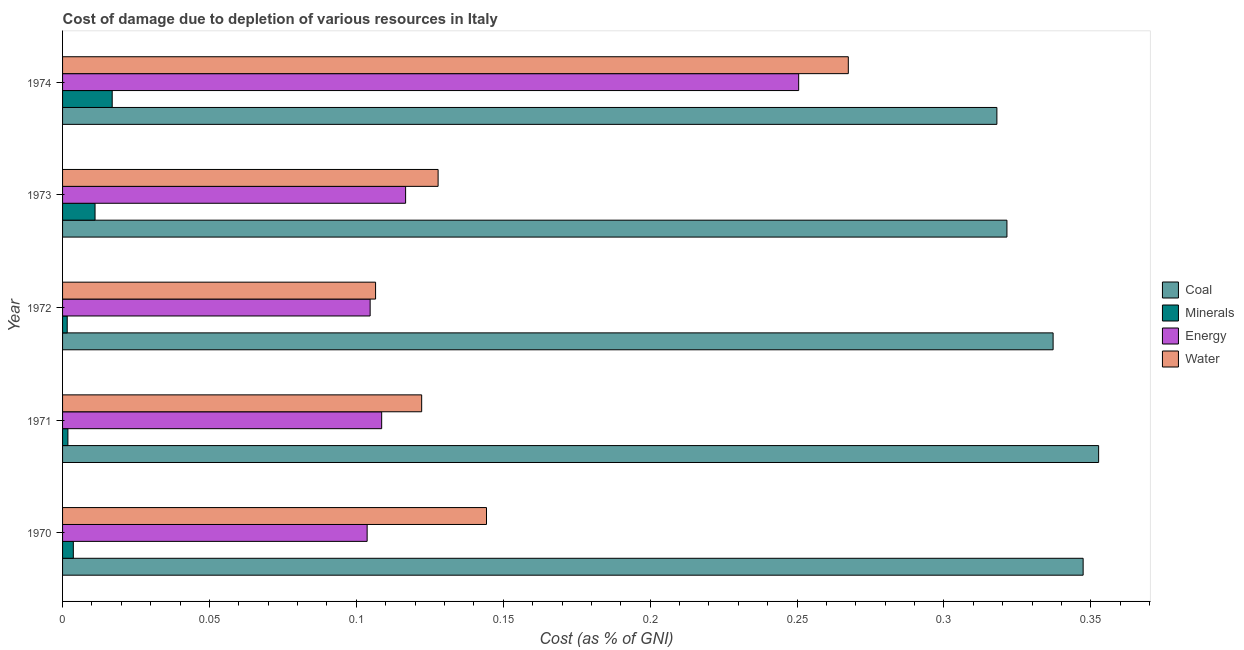How many different coloured bars are there?
Provide a short and direct response. 4. How many bars are there on the 5th tick from the top?
Give a very brief answer. 4. How many bars are there on the 5th tick from the bottom?
Ensure brevity in your answer.  4. What is the label of the 3rd group of bars from the top?
Keep it short and to the point. 1972. What is the cost of damage due to depletion of coal in 1974?
Keep it short and to the point. 0.32. Across all years, what is the maximum cost of damage due to depletion of coal?
Give a very brief answer. 0.35. Across all years, what is the minimum cost of damage due to depletion of energy?
Ensure brevity in your answer.  0.1. In which year was the cost of damage due to depletion of energy maximum?
Your answer should be compact. 1974. What is the total cost of damage due to depletion of water in the graph?
Provide a short and direct response. 0.77. What is the difference between the cost of damage due to depletion of energy in 1970 and that in 1973?
Provide a short and direct response. -0.01. What is the difference between the cost of damage due to depletion of energy in 1970 and the cost of damage due to depletion of water in 1974?
Provide a succinct answer. -0.16. What is the average cost of damage due to depletion of energy per year?
Your answer should be very brief. 0.14. In the year 1971, what is the difference between the cost of damage due to depletion of water and cost of damage due to depletion of energy?
Make the answer very short. 0.01. What is the ratio of the cost of damage due to depletion of coal in 1972 to that in 1973?
Your response must be concise. 1.05. Is the difference between the cost of damage due to depletion of water in 1971 and 1972 greater than the difference between the cost of damage due to depletion of coal in 1971 and 1972?
Offer a very short reply. Yes. What is the difference between the highest and the second highest cost of damage due to depletion of coal?
Keep it short and to the point. 0.01. Is it the case that in every year, the sum of the cost of damage due to depletion of energy and cost of damage due to depletion of water is greater than the sum of cost of damage due to depletion of coal and cost of damage due to depletion of minerals?
Your answer should be compact. No. What does the 3rd bar from the top in 1972 represents?
Offer a terse response. Minerals. What does the 3rd bar from the bottom in 1973 represents?
Your answer should be compact. Energy. How many bars are there?
Keep it short and to the point. 20. What is the difference between two consecutive major ticks on the X-axis?
Your response must be concise. 0.05. Does the graph contain grids?
Provide a short and direct response. No. How many legend labels are there?
Your response must be concise. 4. How are the legend labels stacked?
Offer a very short reply. Vertical. What is the title of the graph?
Your answer should be compact. Cost of damage due to depletion of various resources in Italy . What is the label or title of the X-axis?
Your answer should be very brief. Cost (as % of GNI). What is the label or title of the Y-axis?
Provide a short and direct response. Year. What is the Cost (as % of GNI) in Coal in 1970?
Provide a succinct answer. 0.35. What is the Cost (as % of GNI) in Minerals in 1970?
Provide a succinct answer. 0. What is the Cost (as % of GNI) in Energy in 1970?
Keep it short and to the point. 0.1. What is the Cost (as % of GNI) in Water in 1970?
Keep it short and to the point. 0.14. What is the Cost (as % of GNI) of Coal in 1971?
Your response must be concise. 0.35. What is the Cost (as % of GNI) of Minerals in 1971?
Keep it short and to the point. 0. What is the Cost (as % of GNI) in Energy in 1971?
Your answer should be very brief. 0.11. What is the Cost (as % of GNI) in Water in 1971?
Offer a very short reply. 0.12. What is the Cost (as % of GNI) of Coal in 1972?
Make the answer very short. 0.34. What is the Cost (as % of GNI) of Minerals in 1972?
Keep it short and to the point. 0. What is the Cost (as % of GNI) of Energy in 1972?
Provide a succinct answer. 0.1. What is the Cost (as % of GNI) of Water in 1972?
Provide a short and direct response. 0.11. What is the Cost (as % of GNI) in Coal in 1973?
Offer a terse response. 0.32. What is the Cost (as % of GNI) of Minerals in 1973?
Give a very brief answer. 0.01. What is the Cost (as % of GNI) in Energy in 1973?
Your answer should be very brief. 0.12. What is the Cost (as % of GNI) in Water in 1973?
Provide a short and direct response. 0.13. What is the Cost (as % of GNI) in Coal in 1974?
Provide a short and direct response. 0.32. What is the Cost (as % of GNI) in Minerals in 1974?
Provide a short and direct response. 0.02. What is the Cost (as % of GNI) in Energy in 1974?
Give a very brief answer. 0.25. What is the Cost (as % of GNI) of Water in 1974?
Provide a succinct answer. 0.27. Across all years, what is the maximum Cost (as % of GNI) of Coal?
Make the answer very short. 0.35. Across all years, what is the maximum Cost (as % of GNI) in Minerals?
Your answer should be very brief. 0.02. Across all years, what is the maximum Cost (as % of GNI) in Energy?
Offer a terse response. 0.25. Across all years, what is the maximum Cost (as % of GNI) in Water?
Provide a succinct answer. 0.27. Across all years, what is the minimum Cost (as % of GNI) of Coal?
Your answer should be compact. 0.32. Across all years, what is the minimum Cost (as % of GNI) in Minerals?
Offer a very short reply. 0. Across all years, what is the minimum Cost (as % of GNI) of Energy?
Offer a very short reply. 0.1. Across all years, what is the minimum Cost (as % of GNI) in Water?
Make the answer very short. 0.11. What is the total Cost (as % of GNI) of Coal in the graph?
Ensure brevity in your answer.  1.68. What is the total Cost (as % of GNI) of Minerals in the graph?
Your answer should be compact. 0.04. What is the total Cost (as % of GNI) in Energy in the graph?
Ensure brevity in your answer.  0.68. What is the total Cost (as % of GNI) in Water in the graph?
Provide a succinct answer. 0.77. What is the difference between the Cost (as % of GNI) of Coal in 1970 and that in 1971?
Make the answer very short. -0.01. What is the difference between the Cost (as % of GNI) in Minerals in 1970 and that in 1971?
Offer a terse response. 0. What is the difference between the Cost (as % of GNI) of Energy in 1970 and that in 1971?
Provide a short and direct response. -0. What is the difference between the Cost (as % of GNI) of Water in 1970 and that in 1971?
Keep it short and to the point. 0.02. What is the difference between the Cost (as % of GNI) of Coal in 1970 and that in 1972?
Your answer should be compact. 0.01. What is the difference between the Cost (as % of GNI) of Minerals in 1970 and that in 1972?
Keep it short and to the point. 0. What is the difference between the Cost (as % of GNI) of Energy in 1970 and that in 1972?
Your answer should be compact. -0. What is the difference between the Cost (as % of GNI) in Water in 1970 and that in 1972?
Keep it short and to the point. 0.04. What is the difference between the Cost (as % of GNI) in Coal in 1970 and that in 1973?
Ensure brevity in your answer.  0.03. What is the difference between the Cost (as % of GNI) in Minerals in 1970 and that in 1973?
Keep it short and to the point. -0.01. What is the difference between the Cost (as % of GNI) in Energy in 1970 and that in 1973?
Offer a very short reply. -0.01. What is the difference between the Cost (as % of GNI) in Water in 1970 and that in 1973?
Give a very brief answer. 0.02. What is the difference between the Cost (as % of GNI) of Coal in 1970 and that in 1974?
Provide a succinct answer. 0.03. What is the difference between the Cost (as % of GNI) of Minerals in 1970 and that in 1974?
Your answer should be very brief. -0.01. What is the difference between the Cost (as % of GNI) in Energy in 1970 and that in 1974?
Offer a terse response. -0.15. What is the difference between the Cost (as % of GNI) in Water in 1970 and that in 1974?
Provide a succinct answer. -0.12. What is the difference between the Cost (as % of GNI) of Coal in 1971 and that in 1972?
Keep it short and to the point. 0.02. What is the difference between the Cost (as % of GNI) of Energy in 1971 and that in 1972?
Keep it short and to the point. 0. What is the difference between the Cost (as % of GNI) of Water in 1971 and that in 1972?
Your response must be concise. 0.02. What is the difference between the Cost (as % of GNI) of Coal in 1971 and that in 1973?
Offer a very short reply. 0.03. What is the difference between the Cost (as % of GNI) in Minerals in 1971 and that in 1973?
Make the answer very short. -0.01. What is the difference between the Cost (as % of GNI) in Energy in 1971 and that in 1973?
Offer a terse response. -0.01. What is the difference between the Cost (as % of GNI) in Water in 1971 and that in 1973?
Make the answer very short. -0.01. What is the difference between the Cost (as % of GNI) of Coal in 1971 and that in 1974?
Your response must be concise. 0.03. What is the difference between the Cost (as % of GNI) in Minerals in 1971 and that in 1974?
Offer a terse response. -0.02. What is the difference between the Cost (as % of GNI) of Energy in 1971 and that in 1974?
Offer a very short reply. -0.14. What is the difference between the Cost (as % of GNI) in Water in 1971 and that in 1974?
Your response must be concise. -0.15. What is the difference between the Cost (as % of GNI) of Coal in 1972 and that in 1973?
Provide a succinct answer. 0.02. What is the difference between the Cost (as % of GNI) of Minerals in 1972 and that in 1973?
Provide a succinct answer. -0.01. What is the difference between the Cost (as % of GNI) of Energy in 1972 and that in 1973?
Provide a short and direct response. -0.01. What is the difference between the Cost (as % of GNI) of Water in 1972 and that in 1973?
Offer a terse response. -0.02. What is the difference between the Cost (as % of GNI) in Coal in 1972 and that in 1974?
Offer a terse response. 0.02. What is the difference between the Cost (as % of GNI) of Minerals in 1972 and that in 1974?
Your answer should be compact. -0.02. What is the difference between the Cost (as % of GNI) of Energy in 1972 and that in 1974?
Offer a terse response. -0.15. What is the difference between the Cost (as % of GNI) of Water in 1972 and that in 1974?
Provide a short and direct response. -0.16. What is the difference between the Cost (as % of GNI) of Coal in 1973 and that in 1974?
Provide a succinct answer. 0. What is the difference between the Cost (as % of GNI) of Minerals in 1973 and that in 1974?
Provide a short and direct response. -0.01. What is the difference between the Cost (as % of GNI) in Energy in 1973 and that in 1974?
Your response must be concise. -0.13. What is the difference between the Cost (as % of GNI) of Water in 1973 and that in 1974?
Keep it short and to the point. -0.14. What is the difference between the Cost (as % of GNI) in Coal in 1970 and the Cost (as % of GNI) in Minerals in 1971?
Your answer should be compact. 0.35. What is the difference between the Cost (as % of GNI) of Coal in 1970 and the Cost (as % of GNI) of Energy in 1971?
Keep it short and to the point. 0.24. What is the difference between the Cost (as % of GNI) of Coal in 1970 and the Cost (as % of GNI) of Water in 1971?
Provide a short and direct response. 0.23. What is the difference between the Cost (as % of GNI) of Minerals in 1970 and the Cost (as % of GNI) of Energy in 1971?
Offer a terse response. -0.1. What is the difference between the Cost (as % of GNI) in Minerals in 1970 and the Cost (as % of GNI) in Water in 1971?
Ensure brevity in your answer.  -0.12. What is the difference between the Cost (as % of GNI) in Energy in 1970 and the Cost (as % of GNI) in Water in 1971?
Provide a short and direct response. -0.02. What is the difference between the Cost (as % of GNI) of Coal in 1970 and the Cost (as % of GNI) of Minerals in 1972?
Ensure brevity in your answer.  0.35. What is the difference between the Cost (as % of GNI) in Coal in 1970 and the Cost (as % of GNI) in Energy in 1972?
Provide a short and direct response. 0.24. What is the difference between the Cost (as % of GNI) in Coal in 1970 and the Cost (as % of GNI) in Water in 1972?
Give a very brief answer. 0.24. What is the difference between the Cost (as % of GNI) of Minerals in 1970 and the Cost (as % of GNI) of Energy in 1972?
Offer a terse response. -0.1. What is the difference between the Cost (as % of GNI) of Minerals in 1970 and the Cost (as % of GNI) of Water in 1972?
Provide a succinct answer. -0.1. What is the difference between the Cost (as % of GNI) of Energy in 1970 and the Cost (as % of GNI) of Water in 1972?
Offer a very short reply. -0. What is the difference between the Cost (as % of GNI) of Coal in 1970 and the Cost (as % of GNI) of Minerals in 1973?
Offer a very short reply. 0.34. What is the difference between the Cost (as % of GNI) of Coal in 1970 and the Cost (as % of GNI) of Energy in 1973?
Make the answer very short. 0.23. What is the difference between the Cost (as % of GNI) in Coal in 1970 and the Cost (as % of GNI) in Water in 1973?
Your response must be concise. 0.22. What is the difference between the Cost (as % of GNI) in Minerals in 1970 and the Cost (as % of GNI) in Energy in 1973?
Give a very brief answer. -0.11. What is the difference between the Cost (as % of GNI) in Minerals in 1970 and the Cost (as % of GNI) in Water in 1973?
Your answer should be compact. -0.12. What is the difference between the Cost (as % of GNI) in Energy in 1970 and the Cost (as % of GNI) in Water in 1973?
Provide a short and direct response. -0.02. What is the difference between the Cost (as % of GNI) in Coal in 1970 and the Cost (as % of GNI) in Minerals in 1974?
Your answer should be compact. 0.33. What is the difference between the Cost (as % of GNI) in Coal in 1970 and the Cost (as % of GNI) in Energy in 1974?
Ensure brevity in your answer.  0.1. What is the difference between the Cost (as % of GNI) in Coal in 1970 and the Cost (as % of GNI) in Water in 1974?
Offer a very short reply. 0.08. What is the difference between the Cost (as % of GNI) of Minerals in 1970 and the Cost (as % of GNI) of Energy in 1974?
Offer a terse response. -0.25. What is the difference between the Cost (as % of GNI) in Minerals in 1970 and the Cost (as % of GNI) in Water in 1974?
Provide a succinct answer. -0.26. What is the difference between the Cost (as % of GNI) of Energy in 1970 and the Cost (as % of GNI) of Water in 1974?
Ensure brevity in your answer.  -0.16. What is the difference between the Cost (as % of GNI) of Coal in 1971 and the Cost (as % of GNI) of Minerals in 1972?
Keep it short and to the point. 0.35. What is the difference between the Cost (as % of GNI) of Coal in 1971 and the Cost (as % of GNI) of Energy in 1972?
Your answer should be compact. 0.25. What is the difference between the Cost (as % of GNI) in Coal in 1971 and the Cost (as % of GNI) in Water in 1972?
Provide a short and direct response. 0.25. What is the difference between the Cost (as % of GNI) of Minerals in 1971 and the Cost (as % of GNI) of Energy in 1972?
Give a very brief answer. -0.1. What is the difference between the Cost (as % of GNI) of Minerals in 1971 and the Cost (as % of GNI) of Water in 1972?
Your answer should be compact. -0.1. What is the difference between the Cost (as % of GNI) of Energy in 1971 and the Cost (as % of GNI) of Water in 1972?
Keep it short and to the point. 0. What is the difference between the Cost (as % of GNI) of Coal in 1971 and the Cost (as % of GNI) of Minerals in 1973?
Offer a very short reply. 0.34. What is the difference between the Cost (as % of GNI) in Coal in 1971 and the Cost (as % of GNI) in Energy in 1973?
Your answer should be compact. 0.24. What is the difference between the Cost (as % of GNI) of Coal in 1971 and the Cost (as % of GNI) of Water in 1973?
Your response must be concise. 0.22. What is the difference between the Cost (as % of GNI) in Minerals in 1971 and the Cost (as % of GNI) in Energy in 1973?
Ensure brevity in your answer.  -0.11. What is the difference between the Cost (as % of GNI) in Minerals in 1971 and the Cost (as % of GNI) in Water in 1973?
Offer a very short reply. -0.13. What is the difference between the Cost (as % of GNI) in Energy in 1971 and the Cost (as % of GNI) in Water in 1973?
Ensure brevity in your answer.  -0.02. What is the difference between the Cost (as % of GNI) in Coal in 1971 and the Cost (as % of GNI) in Minerals in 1974?
Provide a succinct answer. 0.34. What is the difference between the Cost (as % of GNI) in Coal in 1971 and the Cost (as % of GNI) in Energy in 1974?
Give a very brief answer. 0.1. What is the difference between the Cost (as % of GNI) in Coal in 1971 and the Cost (as % of GNI) in Water in 1974?
Make the answer very short. 0.09. What is the difference between the Cost (as % of GNI) in Minerals in 1971 and the Cost (as % of GNI) in Energy in 1974?
Provide a short and direct response. -0.25. What is the difference between the Cost (as % of GNI) of Minerals in 1971 and the Cost (as % of GNI) of Water in 1974?
Offer a very short reply. -0.27. What is the difference between the Cost (as % of GNI) of Energy in 1971 and the Cost (as % of GNI) of Water in 1974?
Keep it short and to the point. -0.16. What is the difference between the Cost (as % of GNI) of Coal in 1972 and the Cost (as % of GNI) of Minerals in 1973?
Offer a terse response. 0.33. What is the difference between the Cost (as % of GNI) in Coal in 1972 and the Cost (as % of GNI) in Energy in 1973?
Keep it short and to the point. 0.22. What is the difference between the Cost (as % of GNI) of Coal in 1972 and the Cost (as % of GNI) of Water in 1973?
Offer a terse response. 0.21. What is the difference between the Cost (as % of GNI) in Minerals in 1972 and the Cost (as % of GNI) in Energy in 1973?
Keep it short and to the point. -0.12. What is the difference between the Cost (as % of GNI) in Minerals in 1972 and the Cost (as % of GNI) in Water in 1973?
Make the answer very short. -0.13. What is the difference between the Cost (as % of GNI) of Energy in 1972 and the Cost (as % of GNI) of Water in 1973?
Keep it short and to the point. -0.02. What is the difference between the Cost (as % of GNI) of Coal in 1972 and the Cost (as % of GNI) of Minerals in 1974?
Ensure brevity in your answer.  0.32. What is the difference between the Cost (as % of GNI) in Coal in 1972 and the Cost (as % of GNI) in Energy in 1974?
Offer a terse response. 0.09. What is the difference between the Cost (as % of GNI) in Coal in 1972 and the Cost (as % of GNI) in Water in 1974?
Provide a short and direct response. 0.07. What is the difference between the Cost (as % of GNI) of Minerals in 1972 and the Cost (as % of GNI) of Energy in 1974?
Keep it short and to the point. -0.25. What is the difference between the Cost (as % of GNI) of Minerals in 1972 and the Cost (as % of GNI) of Water in 1974?
Ensure brevity in your answer.  -0.27. What is the difference between the Cost (as % of GNI) of Energy in 1972 and the Cost (as % of GNI) of Water in 1974?
Your answer should be compact. -0.16. What is the difference between the Cost (as % of GNI) in Coal in 1973 and the Cost (as % of GNI) in Minerals in 1974?
Provide a succinct answer. 0.3. What is the difference between the Cost (as % of GNI) in Coal in 1973 and the Cost (as % of GNI) in Energy in 1974?
Provide a succinct answer. 0.07. What is the difference between the Cost (as % of GNI) of Coal in 1973 and the Cost (as % of GNI) of Water in 1974?
Make the answer very short. 0.05. What is the difference between the Cost (as % of GNI) of Minerals in 1973 and the Cost (as % of GNI) of Energy in 1974?
Give a very brief answer. -0.24. What is the difference between the Cost (as % of GNI) in Minerals in 1973 and the Cost (as % of GNI) in Water in 1974?
Ensure brevity in your answer.  -0.26. What is the difference between the Cost (as % of GNI) in Energy in 1973 and the Cost (as % of GNI) in Water in 1974?
Offer a terse response. -0.15. What is the average Cost (as % of GNI) in Coal per year?
Make the answer very short. 0.34. What is the average Cost (as % of GNI) in Minerals per year?
Offer a very short reply. 0.01. What is the average Cost (as % of GNI) in Energy per year?
Give a very brief answer. 0.14. What is the average Cost (as % of GNI) in Water per year?
Keep it short and to the point. 0.15. In the year 1970, what is the difference between the Cost (as % of GNI) in Coal and Cost (as % of GNI) in Minerals?
Give a very brief answer. 0.34. In the year 1970, what is the difference between the Cost (as % of GNI) in Coal and Cost (as % of GNI) in Energy?
Offer a very short reply. 0.24. In the year 1970, what is the difference between the Cost (as % of GNI) of Coal and Cost (as % of GNI) of Water?
Offer a very short reply. 0.2. In the year 1970, what is the difference between the Cost (as % of GNI) in Minerals and Cost (as % of GNI) in Water?
Your response must be concise. -0.14. In the year 1970, what is the difference between the Cost (as % of GNI) in Energy and Cost (as % of GNI) in Water?
Offer a terse response. -0.04. In the year 1971, what is the difference between the Cost (as % of GNI) in Coal and Cost (as % of GNI) in Minerals?
Your answer should be compact. 0.35. In the year 1971, what is the difference between the Cost (as % of GNI) of Coal and Cost (as % of GNI) of Energy?
Provide a short and direct response. 0.24. In the year 1971, what is the difference between the Cost (as % of GNI) of Coal and Cost (as % of GNI) of Water?
Offer a very short reply. 0.23. In the year 1971, what is the difference between the Cost (as % of GNI) in Minerals and Cost (as % of GNI) in Energy?
Make the answer very short. -0.11. In the year 1971, what is the difference between the Cost (as % of GNI) in Minerals and Cost (as % of GNI) in Water?
Ensure brevity in your answer.  -0.12. In the year 1971, what is the difference between the Cost (as % of GNI) in Energy and Cost (as % of GNI) in Water?
Offer a terse response. -0.01. In the year 1972, what is the difference between the Cost (as % of GNI) in Coal and Cost (as % of GNI) in Minerals?
Provide a succinct answer. 0.34. In the year 1972, what is the difference between the Cost (as % of GNI) of Coal and Cost (as % of GNI) of Energy?
Your response must be concise. 0.23. In the year 1972, what is the difference between the Cost (as % of GNI) in Coal and Cost (as % of GNI) in Water?
Your response must be concise. 0.23. In the year 1972, what is the difference between the Cost (as % of GNI) in Minerals and Cost (as % of GNI) in Energy?
Make the answer very short. -0.1. In the year 1972, what is the difference between the Cost (as % of GNI) of Minerals and Cost (as % of GNI) of Water?
Provide a short and direct response. -0.1. In the year 1972, what is the difference between the Cost (as % of GNI) of Energy and Cost (as % of GNI) of Water?
Your response must be concise. -0. In the year 1973, what is the difference between the Cost (as % of GNI) in Coal and Cost (as % of GNI) in Minerals?
Your response must be concise. 0.31. In the year 1973, what is the difference between the Cost (as % of GNI) of Coal and Cost (as % of GNI) of Energy?
Provide a succinct answer. 0.2. In the year 1973, what is the difference between the Cost (as % of GNI) of Coal and Cost (as % of GNI) of Water?
Offer a very short reply. 0.19. In the year 1973, what is the difference between the Cost (as % of GNI) of Minerals and Cost (as % of GNI) of Energy?
Keep it short and to the point. -0.11. In the year 1973, what is the difference between the Cost (as % of GNI) of Minerals and Cost (as % of GNI) of Water?
Provide a succinct answer. -0.12. In the year 1973, what is the difference between the Cost (as % of GNI) of Energy and Cost (as % of GNI) of Water?
Your answer should be very brief. -0.01. In the year 1974, what is the difference between the Cost (as % of GNI) of Coal and Cost (as % of GNI) of Minerals?
Offer a very short reply. 0.3. In the year 1974, what is the difference between the Cost (as % of GNI) of Coal and Cost (as % of GNI) of Energy?
Give a very brief answer. 0.07. In the year 1974, what is the difference between the Cost (as % of GNI) of Coal and Cost (as % of GNI) of Water?
Your answer should be very brief. 0.05. In the year 1974, what is the difference between the Cost (as % of GNI) in Minerals and Cost (as % of GNI) in Energy?
Provide a succinct answer. -0.23. In the year 1974, what is the difference between the Cost (as % of GNI) in Minerals and Cost (as % of GNI) in Water?
Your answer should be very brief. -0.25. In the year 1974, what is the difference between the Cost (as % of GNI) in Energy and Cost (as % of GNI) in Water?
Your answer should be very brief. -0.02. What is the ratio of the Cost (as % of GNI) in Coal in 1970 to that in 1971?
Provide a succinct answer. 0.98. What is the ratio of the Cost (as % of GNI) in Minerals in 1970 to that in 1971?
Give a very brief answer. 2.01. What is the ratio of the Cost (as % of GNI) of Energy in 1970 to that in 1971?
Provide a succinct answer. 0.95. What is the ratio of the Cost (as % of GNI) of Water in 1970 to that in 1971?
Make the answer very short. 1.18. What is the ratio of the Cost (as % of GNI) in Coal in 1970 to that in 1972?
Make the answer very short. 1.03. What is the ratio of the Cost (as % of GNI) in Minerals in 1970 to that in 1972?
Offer a terse response. 2.31. What is the ratio of the Cost (as % of GNI) in Energy in 1970 to that in 1972?
Your answer should be very brief. 0.99. What is the ratio of the Cost (as % of GNI) of Water in 1970 to that in 1972?
Keep it short and to the point. 1.35. What is the ratio of the Cost (as % of GNI) of Coal in 1970 to that in 1973?
Provide a succinct answer. 1.08. What is the ratio of the Cost (as % of GNI) in Minerals in 1970 to that in 1973?
Your response must be concise. 0.33. What is the ratio of the Cost (as % of GNI) of Energy in 1970 to that in 1973?
Your response must be concise. 0.89. What is the ratio of the Cost (as % of GNI) of Water in 1970 to that in 1973?
Your answer should be very brief. 1.13. What is the ratio of the Cost (as % of GNI) in Coal in 1970 to that in 1974?
Provide a short and direct response. 1.09. What is the ratio of the Cost (as % of GNI) of Minerals in 1970 to that in 1974?
Keep it short and to the point. 0.22. What is the ratio of the Cost (as % of GNI) of Energy in 1970 to that in 1974?
Your response must be concise. 0.41. What is the ratio of the Cost (as % of GNI) in Water in 1970 to that in 1974?
Offer a very short reply. 0.54. What is the ratio of the Cost (as % of GNI) in Coal in 1971 to that in 1972?
Offer a terse response. 1.05. What is the ratio of the Cost (as % of GNI) of Minerals in 1971 to that in 1972?
Give a very brief answer. 1.15. What is the ratio of the Cost (as % of GNI) of Energy in 1971 to that in 1972?
Keep it short and to the point. 1.04. What is the ratio of the Cost (as % of GNI) of Water in 1971 to that in 1972?
Your answer should be very brief. 1.15. What is the ratio of the Cost (as % of GNI) of Coal in 1971 to that in 1973?
Give a very brief answer. 1.1. What is the ratio of the Cost (as % of GNI) in Minerals in 1971 to that in 1973?
Offer a terse response. 0.16. What is the ratio of the Cost (as % of GNI) in Energy in 1971 to that in 1973?
Your answer should be very brief. 0.93. What is the ratio of the Cost (as % of GNI) of Water in 1971 to that in 1973?
Provide a succinct answer. 0.96. What is the ratio of the Cost (as % of GNI) in Coal in 1971 to that in 1974?
Make the answer very short. 1.11. What is the ratio of the Cost (as % of GNI) of Minerals in 1971 to that in 1974?
Your answer should be very brief. 0.11. What is the ratio of the Cost (as % of GNI) of Energy in 1971 to that in 1974?
Offer a very short reply. 0.43. What is the ratio of the Cost (as % of GNI) in Water in 1971 to that in 1974?
Your answer should be compact. 0.46. What is the ratio of the Cost (as % of GNI) in Coal in 1972 to that in 1973?
Make the answer very short. 1.05. What is the ratio of the Cost (as % of GNI) of Minerals in 1972 to that in 1973?
Your answer should be compact. 0.14. What is the ratio of the Cost (as % of GNI) of Energy in 1972 to that in 1973?
Give a very brief answer. 0.9. What is the ratio of the Cost (as % of GNI) in Water in 1972 to that in 1973?
Your answer should be compact. 0.83. What is the ratio of the Cost (as % of GNI) in Coal in 1972 to that in 1974?
Give a very brief answer. 1.06. What is the ratio of the Cost (as % of GNI) of Minerals in 1972 to that in 1974?
Your answer should be compact. 0.09. What is the ratio of the Cost (as % of GNI) of Energy in 1972 to that in 1974?
Your answer should be compact. 0.42. What is the ratio of the Cost (as % of GNI) in Water in 1972 to that in 1974?
Ensure brevity in your answer.  0.4. What is the ratio of the Cost (as % of GNI) of Coal in 1973 to that in 1974?
Your answer should be very brief. 1.01. What is the ratio of the Cost (as % of GNI) of Minerals in 1973 to that in 1974?
Ensure brevity in your answer.  0.65. What is the ratio of the Cost (as % of GNI) of Energy in 1973 to that in 1974?
Provide a short and direct response. 0.47. What is the ratio of the Cost (as % of GNI) in Water in 1973 to that in 1974?
Your response must be concise. 0.48. What is the difference between the highest and the second highest Cost (as % of GNI) in Coal?
Keep it short and to the point. 0.01. What is the difference between the highest and the second highest Cost (as % of GNI) in Minerals?
Your answer should be very brief. 0.01. What is the difference between the highest and the second highest Cost (as % of GNI) in Energy?
Offer a terse response. 0.13. What is the difference between the highest and the second highest Cost (as % of GNI) of Water?
Give a very brief answer. 0.12. What is the difference between the highest and the lowest Cost (as % of GNI) in Coal?
Your answer should be very brief. 0.03. What is the difference between the highest and the lowest Cost (as % of GNI) of Minerals?
Make the answer very short. 0.02. What is the difference between the highest and the lowest Cost (as % of GNI) of Energy?
Offer a terse response. 0.15. What is the difference between the highest and the lowest Cost (as % of GNI) in Water?
Your answer should be very brief. 0.16. 